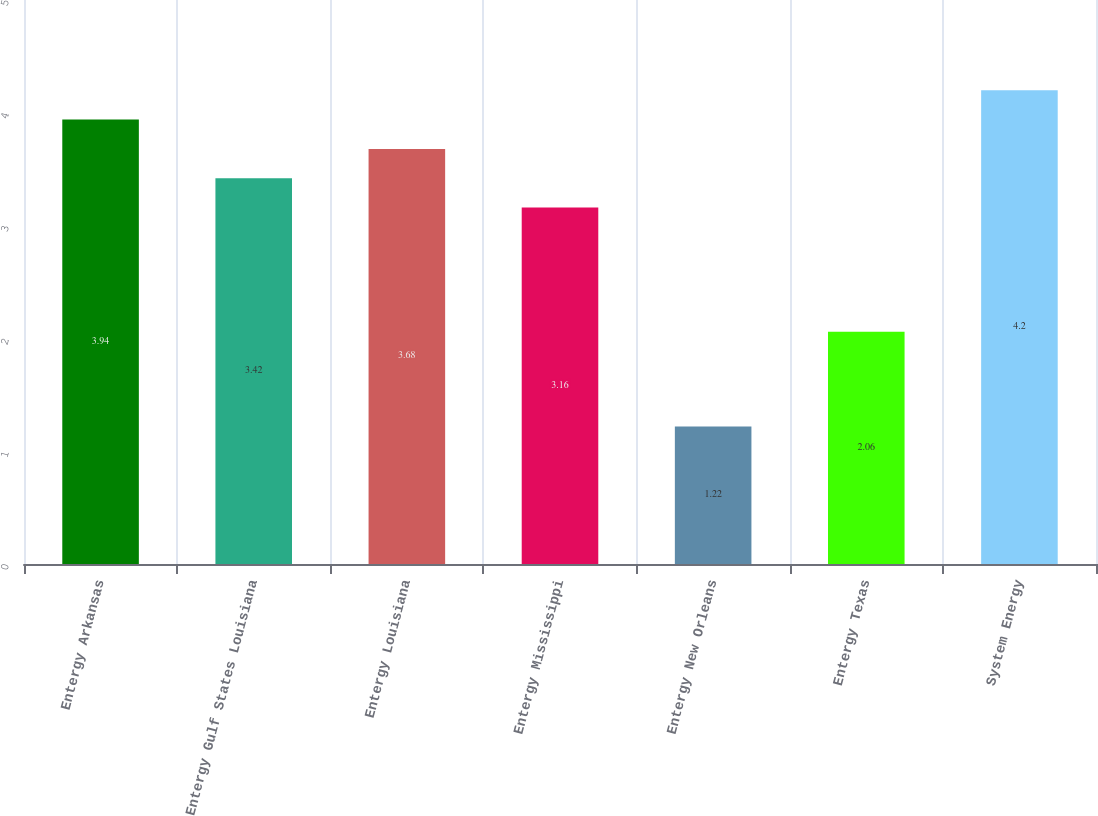Convert chart to OTSL. <chart><loc_0><loc_0><loc_500><loc_500><bar_chart><fcel>Entergy Arkansas<fcel>Entergy Gulf States Louisiana<fcel>Entergy Louisiana<fcel>Entergy Mississippi<fcel>Entergy New Orleans<fcel>Entergy Texas<fcel>System Energy<nl><fcel>3.94<fcel>3.42<fcel>3.68<fcel>3.16<fcel>1.22<fcel>2.06<fcel>4.2<nl></chart> 